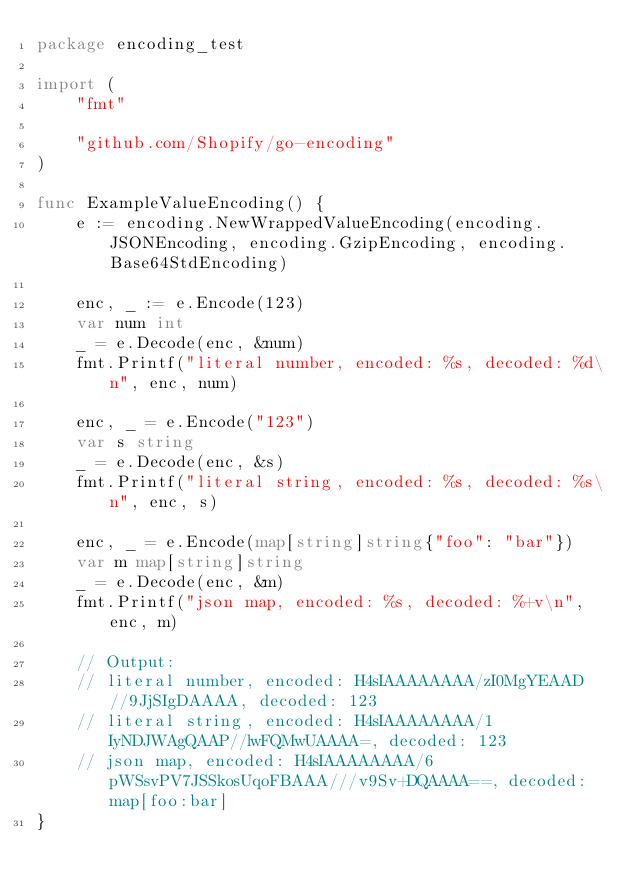<code> <loc_0><loc_0><loc_500><loc_500><_Go_>package encoding_test

import (
	"fmt"

	"github.com/Shopify/go-encoding"
)

func ExampleValueEncoding() {
	e := encoding.NewWrappedValueEncoding(encoding.JSONEncoding, encoding.GzipEncoding, encoding.Base64StdEncoding)

	enc, _ := e.Encode(123)
	var num int
	_ = e.Decode(enc, &num)
	fmt.Printf("literal number, encoded: %s, decoded: %d\n", enc, num)

	enc, _ = e.Encode("123")
	var s string
	_ = e.Decode(enc, &s)
	fmt.Printf("literal string, encoded: %s, decoded: %s\n", enc, s)

	enc, _ = e.Encode(map[string]string{"foo": "bar"})
	var m map[string]string
	_ = e.Decode(enc, &m)
	fmt.Printf("json map, encoded: %s, decoded: %+v\n", enc, m)

	// Output:
	// literal number, encoded: H4sIAAAAAAAA/zI0MgYEAAD//9JjSIgDAAAA, decoded: 123
	// literal string, encoded: H4sIAAAAAAAA/1IyNDJWAgQAAP//lwFQMwUAAAA=, decoded: 123
	// json map, encoded: H4sIAAAAAAAA/6pWSsvPV7JSSkosUqoFBAAA///v9Sv+DQAAAA==, decoded: map[foo:bar]
}
</code> 